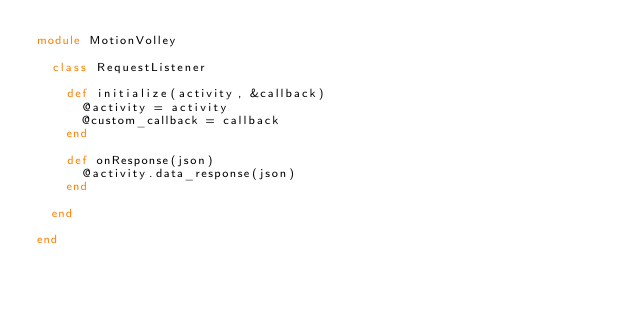Convert code to text. <code><loc_0><loc_0><loc_500><loc_500><_Ruby_>module MotionVolley

  class RequestListener

    def initialize(activity, &callback)
      @activity = activity
      @custom_callback = callback
    end

    def onResponse(json)
      @activity.data_response(json)
    end

  end

end
</code> 